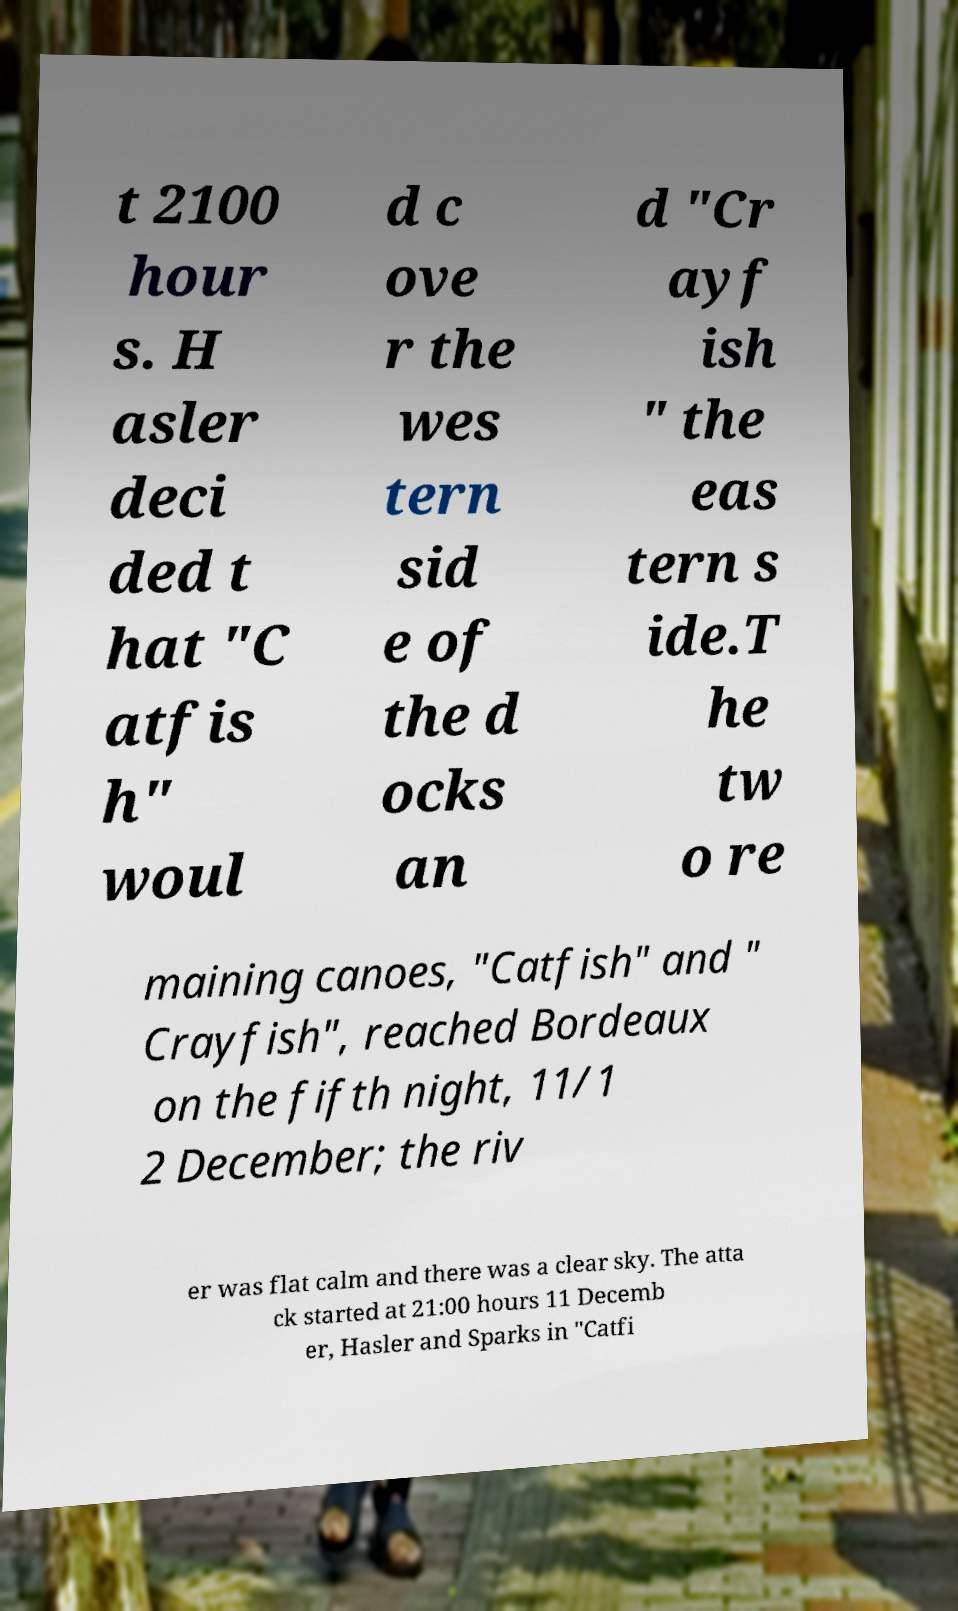There's text embedded in this image that I need extracted. Can you transcribe it verbatim? t 2100 hour s. H asler deci ded t hat "C atfis h" woul d c ove r the wes tern sid e of the d ocks an d "Cr ayf ish " the eas tern s ide.T he tw o re maining canoes, "Catfish" and " Crayfish", reached Bordeaux on the fifth night, 11/1 2 December; the riv er was flat calm and there was a clear sky. The atta ck started at 21:00 hours 11 Decemb er, Hasler and Sparks in "Catfi 